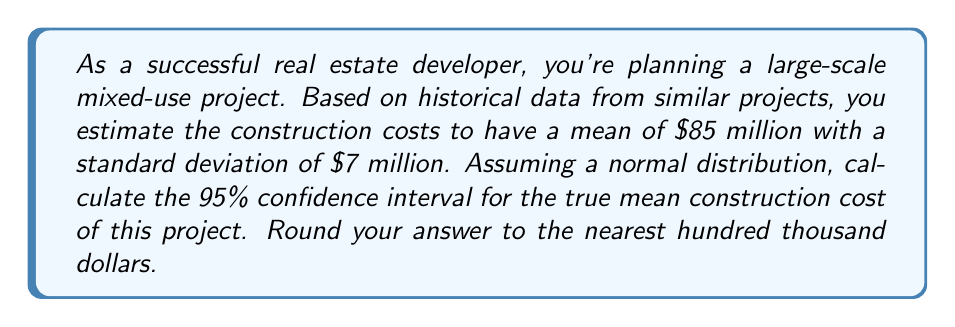Give your solution to this math problem. To calculate the 95% confidence interval, we'll follow these steps:

1. Identify the known values:
   - Sample mean (x̄) = $85 million
   - Standard deviation (s) = $7 million
   - Sample size (n) = not given, but we'll assume it's based on a large sample, so we'll use z-score
   - Confidence level = 95%, so z-score = 1.96

2. Use the formula for confidence interval:
   $$ CI = \bar{x} \pm z \cdot \frac{s}{\sqrt{n}} $$

3. Since we don't have a specific sample size, we'll use the standard error of the mean (SEM):
   $$ SEM = \frac{s}{\sqrt{n}} = 7 \text{ million} $$

4. Calculate the margin of error:
   $$ \text{Margin of Error} = z \cdot SEM = 1.96 \cdot 7 \text{ million} = 13.72 \text{ million} $$

5. Calculate the confidence interval:
   $$ CI = 85 \text{ million} \pm 13.72 \text{ million} $$

6. Find the lower and upper bounds:
   Lower bound: $85 - 13.72 = 71.28 \text{ million}$
   Upper bound: $85 + 13.72 = 98.72 \text{ million}$

7. Round to the nearest hundred thousand:
   Lower bound: $71.3 \text{ million}$
   Upper bound: $98.7 \text{ million}$
Answer: ($71.3 million, $98.7 million) 